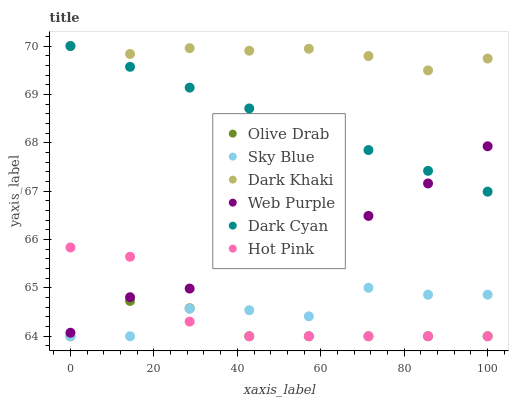Does Olive Drab have the minimum area under the curve?
Answer yes or no. Yes. Does Dark Khaki have the maximum area under the curve?
Answer yes or no. Yes. Does Web Purple have the minimum area under the curve?
Answer yes or no. No. Does Web Purple have the maximum area under the curve?
Answer yes or no. No. Is Dark Cyan the smoothest?
Answer yes or no. Yes. Is Sky Blue the roughest?
Answer yes or no. Yes. Is Dark Khaki the smoothest?
Answer yes or no. No. Is Dark Khaki the roughest?
Answer yes or no. No. Does Hot Pink have the lowest value?
Answer yes or no. Yes. Does Web Purple have the lowest value?
Answer yes or no. No. Does Dark Cyan have the highest value?
Answer yes or no. Yes. Does Web Purple have the highest value?
Answer yes or no. No. Is Hot Pink less than Dark Khaki?
Answer yes or no. Yes. Is Dark Cyan greater than Hot Pink?
Answer yes or no. Yes. Does Web Purple intersect Dark Cyan?
Answer yes or no. Yes. Is Web Purple less than Dark Cyan?
Answer yes or no. No. Is Web Purple greater than Dark Cyan?
Answer yes or no. No. Does Hot Pink intersect Dark Khaki?
Answer yes or no. No. 